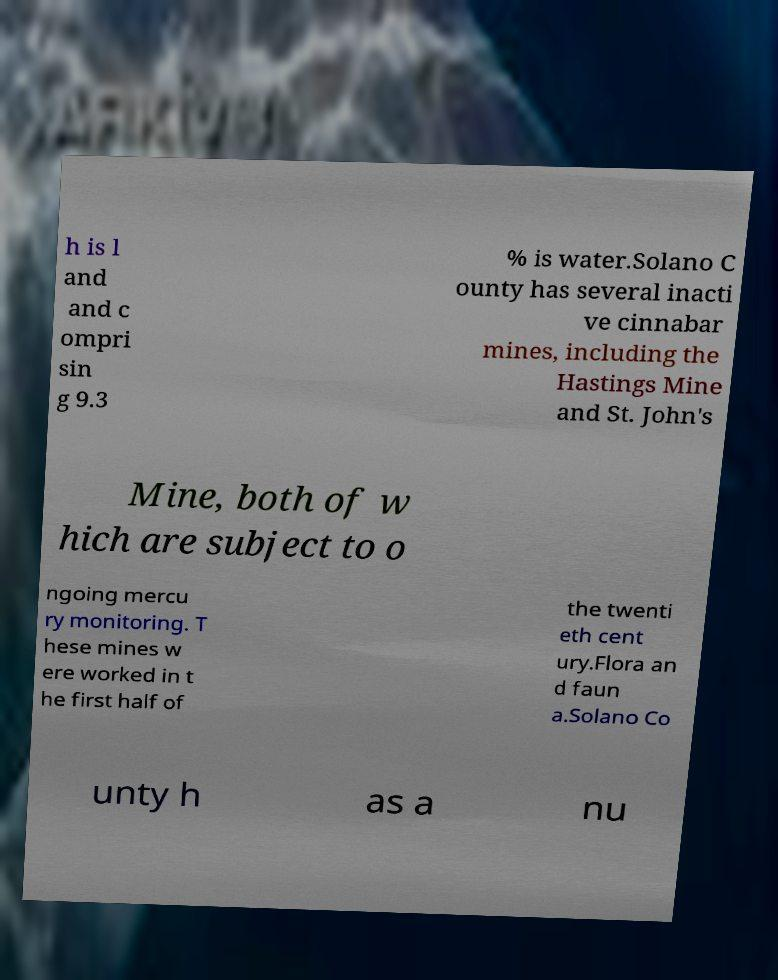There's text embedded in this image that I need extracted. Can you transcribe it verbatim? h is l and and c ompri sin g 9.3 % is water.Solano C ounty has several inacti ve cinnabar mines, including the Hastings Mine and St. John's Mine, both of w hich are subject to o ngoing mercu ry monitoring. T hese mines w ere worked in t he first half of the twenti eth cent ury.Flora an d faun a.Solano Co unty h as a nu 